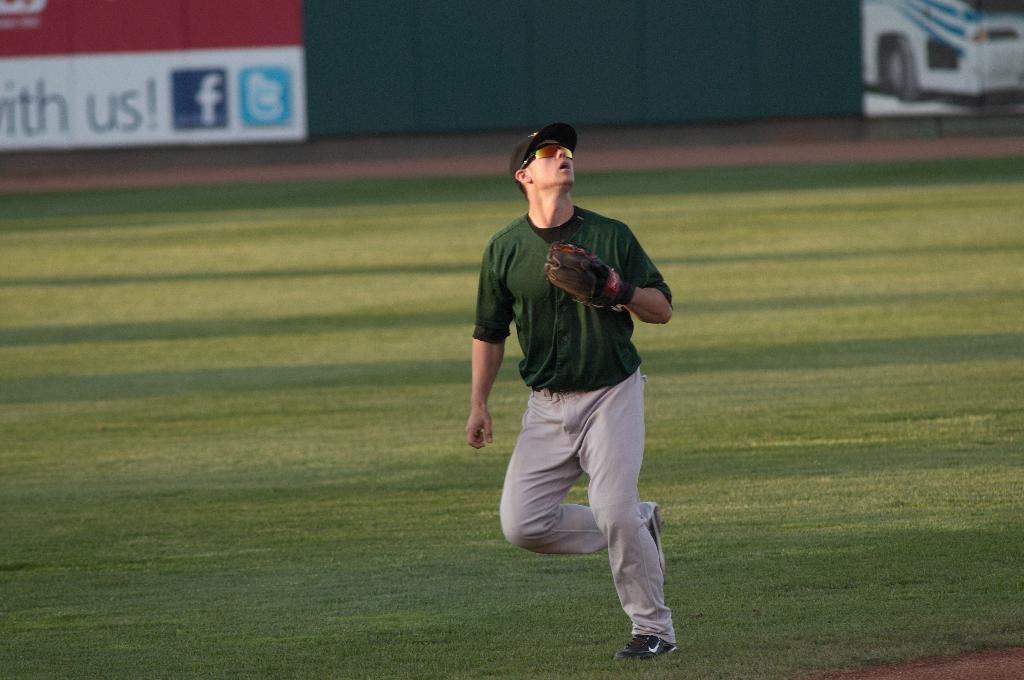<image>
Present a compact description of the photo's key features. a player with the word us in the background 